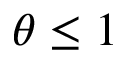Convert formula to latex. <formula><loc_0><loc_0><loc_500><loc_500>\theta \leq 1</formula> 